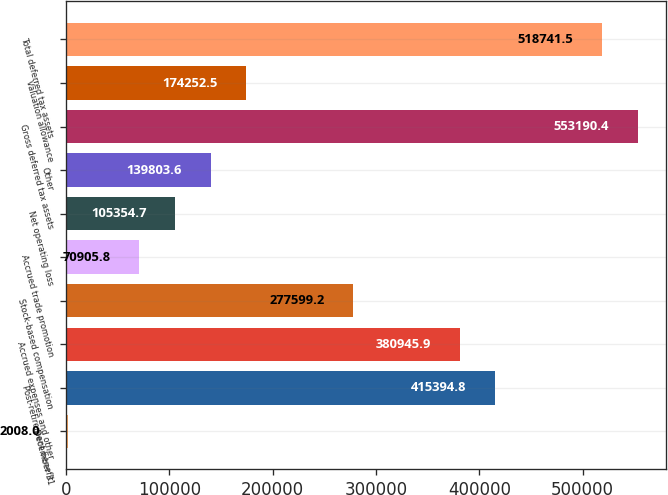<chart> <loc_0><loc_0><loc_500><loc_500><bar_chart><fcel>December 31<fcel>Post-retirement benefit<fcel>Accrued expenses and other<fcel>Stock-based compensation<fcel>Accrued trade promotion<fcel>Net operating loss<fcel>Other<fcel>Gross deferred tax assets<fcel>Valuation allowance<fcel>Total deferred tax assets<nl><fcel>2008<fcel>415395<fcel>380946<fcel>277599<fcel>70905.8<fcel>105355<fcel>139804<fcel>553190<fcel>174252<fcel>518742<nl></chart> 